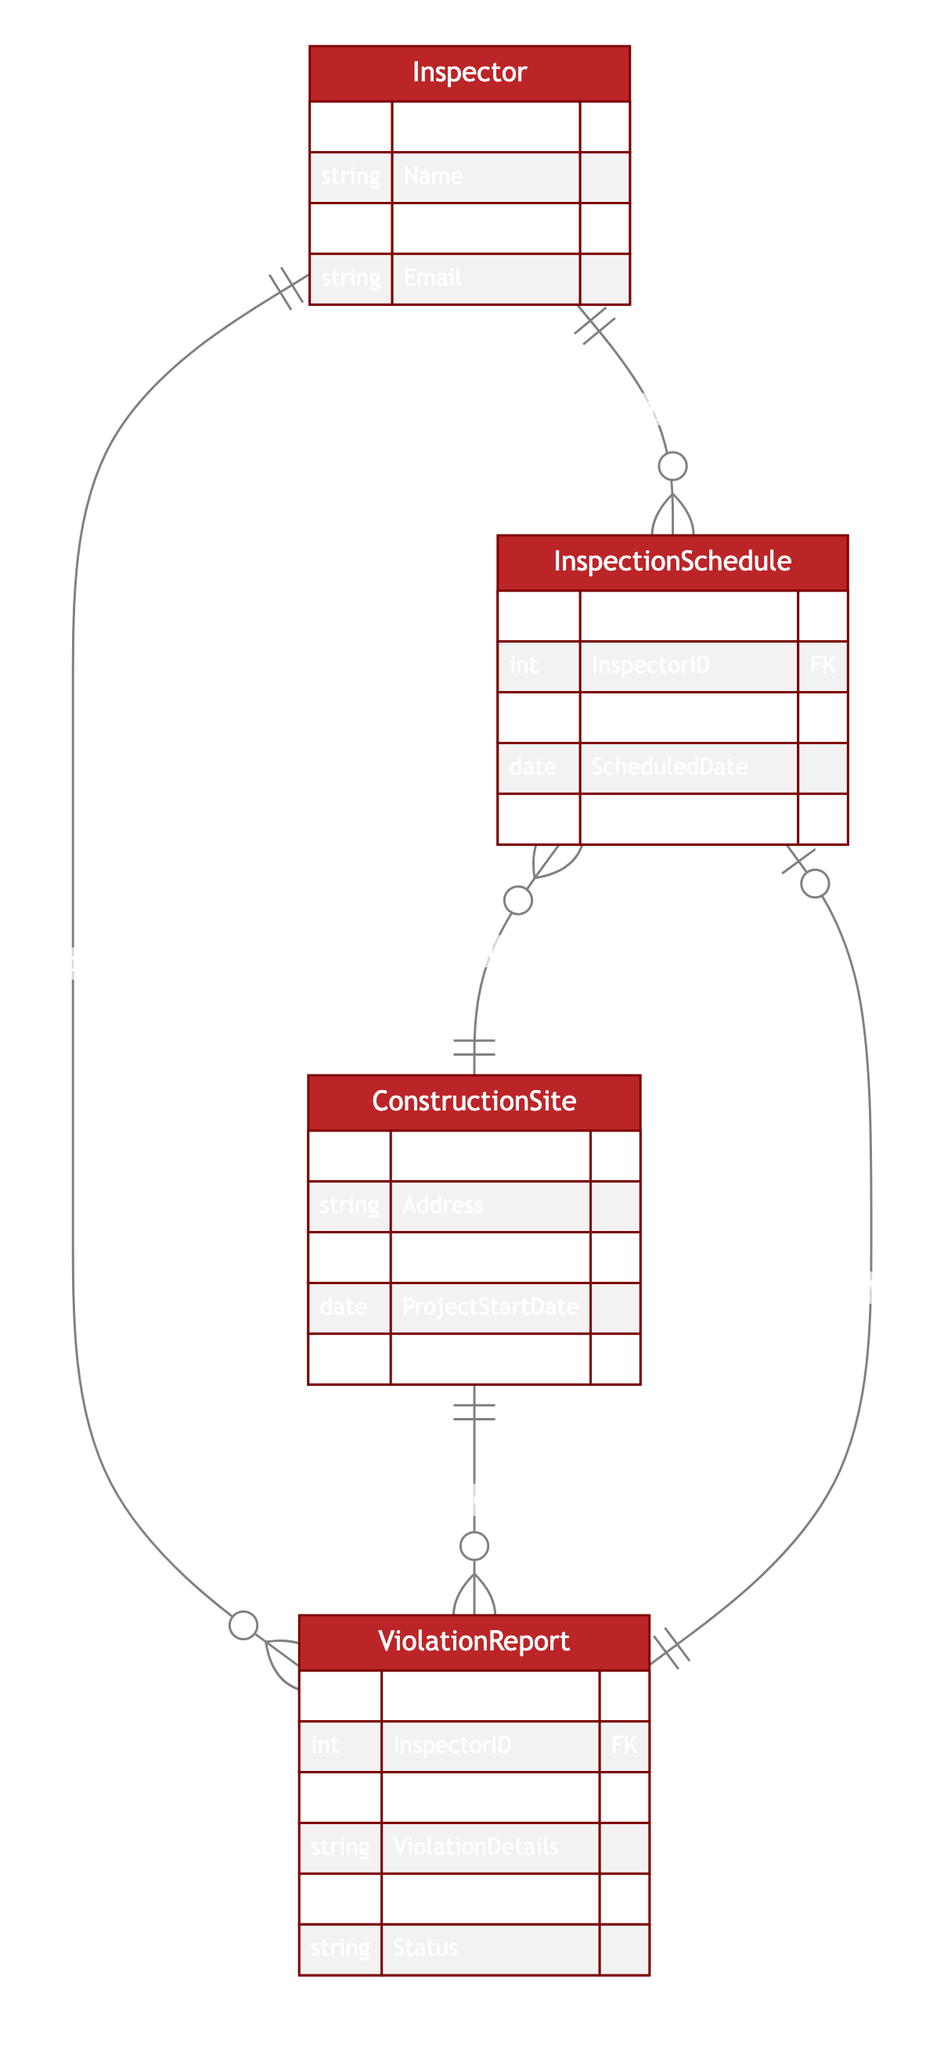What entities are represented in the diagram? The diagram includes four entities: Inspector, InspectionSchedule, ConstructionSite, and ViolationReport.
Answer: Inspector, InspectionSchedule, ConstructionSite, ViolationReport How many primary keys are there in the InspectionSchedule entity? The InspectionSchedule entity has one primary key identified as ScheduleID.
Answer: One What type of relationship exists between Inspector and InspectionSchedule? The relationship is a One-to-Many type, indicating that one inspector can be assigned to multiple inspection schedules.
Answer: One-to-Many Which entity is responsible for reporting violations? The ViolationReport entity is responsible for reporting violations related to construction sites.
Answer: ViolationReport How many times can a ViolationReport follow up on an InspectionSchedule? Each ViolationReport can follow up on exactly one InspectionSchedule, resulting in a One-to-One relationship.
Answer: One Which entity can be scheduled at multiple construction sites? The InspectionSchedule can be scheduled at multiple construction sites as denoted by its relationship to ConstructionSite.
Answer: InspectionSchedule What is the relationship between ConstructionSite and ViolationReport? The relationship is One-to-Many, meaning one construction site can have multiple violation reports associated with it.
Answer: One-to-Many Who conducts the inspections according to the diagram? The inspections are conducted by Inspectors, as indicated by the relationship between Inspector and ViolationReport.
Answer: Inspectors What attribute is common between Inspector and ViolationReport entities? The common attribute is InspectorID, which links the two entities through the relationship.
Answer: InspectorID How many inspection schedules can be assigned to a single inspector? An inspector can be assigned multiple inspection schedules, indicating a One-to-Many relationship.
Answer: Multiple 